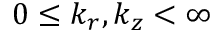Convert formula to latex. <formula><loc_0><loc_0><loc_500><loc_500>0 \leq k _ { r } , k _ { z } < \infty</formula> 